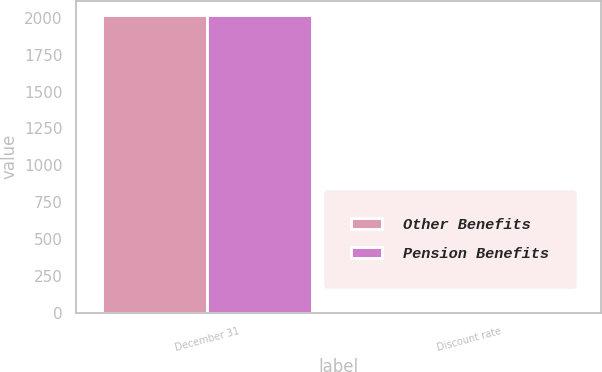Convert chart. <chart><loc_0><loc_0><loc_500><loc_500><stacked_bar_chart><ecel><fcel>December 31<fcel>Discount rate<nl><fcel>Other Benefits<fcel>2016<fcel>4<nl><fcel>Pension Benefits<fcel>2016<fcel>4<nl></chart> 